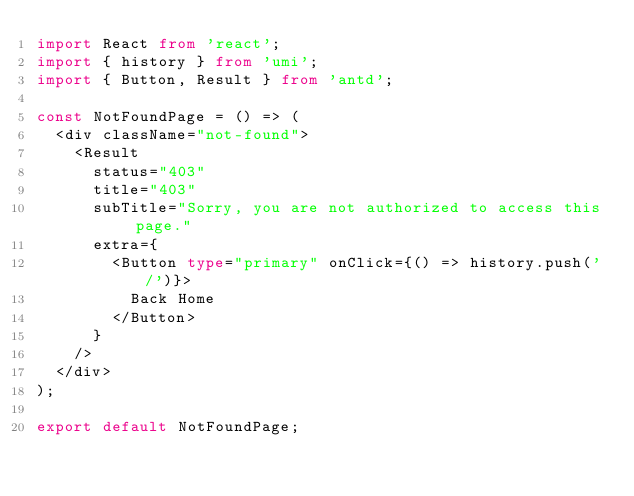<code> <loc_0><loc_0><loc_500><loc_500><_TypeScript_>import React from 'react';
import { history } from 'umi';
import { Button, Result } from 'antd';

const NotFoundPage = () => (
  <div className="not-found">
    <Result
      status="403"
      title="403"
      subTitle="Sorry, you are not authorized to access this page."
      extra={
        <Button type="primary" onClick={() => history.push('/')}>
          Back Home
        </Button>
      }
    />
  </div>
);

export default NotFoundPage;
</code> 